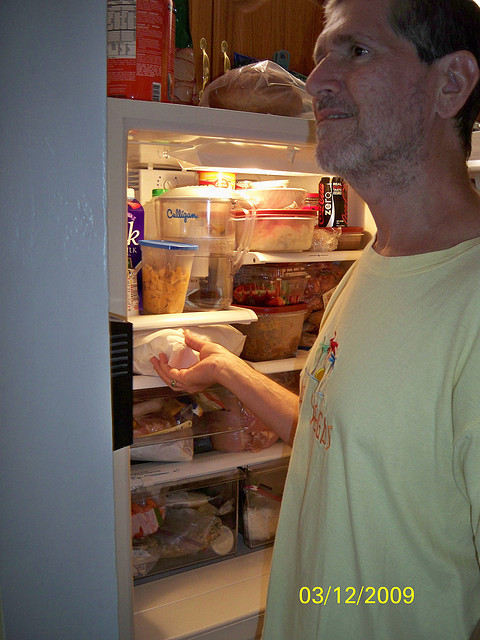<image>What fruit is on the top shelf? It is unclear what fruit is on the top shelf. It could be strawberry or pineapple. What fruit is on the top shelf? I am not sure what fruit is on the top shelf. It can be seen strawberry, pineapple or pineapple chunks. 